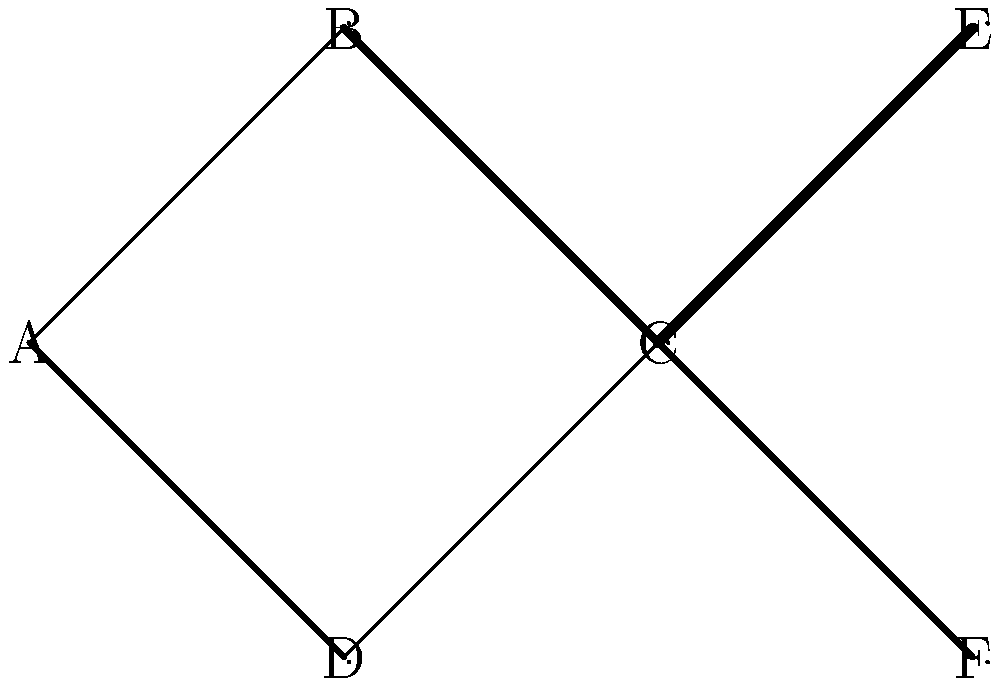In the given neural network diagram, identify the path from node A to node E that has the highest cumulative weight. What is the total weight of this path? To solve this problem, we need to consider all possible paths from node A to node E and calculate their cumulative weights. Let's break it down step-by-step:

1. Identify all possible paths from A to E:
   - Path 1: A → B → C → E
   - Path 2: A → D → C → E

2. Calculate the cumulative weight for each path:
   
   Path 1: A → B → C → E
   - A to B: weight = 0.5
   - B to C: weight = 1.5
   - C to E: weight = 2
   Total weight = 0.5 + 1.5 + 2 = 4

   Path 2: A → D → C → E
   - A to D: weight = 1
   - D to C: weight = 0.5
   - C to E: weight = 2
   Total weight = 1 + 0.5 + 2 = 3.5

3. Compare the cumulative weights:
   Path 1 has a total weight of 4
   Path 2 has a total weight of 3.5

4. Identify the path with the highest cumulative weight:
   Path 1 (A → B → C → E) has the highest cumulative weight of 4.

Therefore, the path from node A to node E that has the highest cumulative weight is A → B → C → E, with a total weight of 4.
Answer: 4 